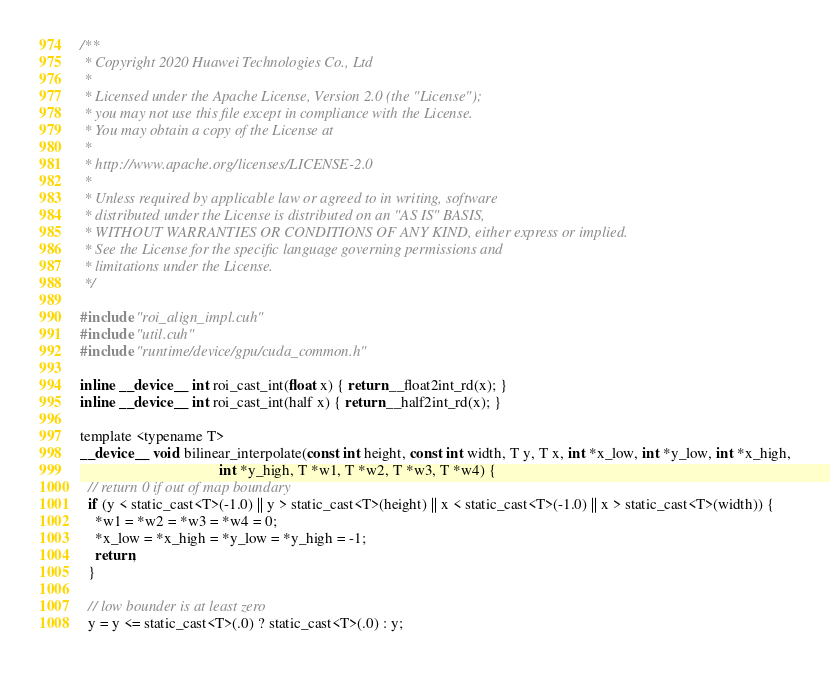<code> <loc_0><loc_0><loc_500><loc_500><_Cuda_>/**
 * Copyright 2020 Huawei Technologies Co., Ltd
 *
 * Licensed under the Apache License, Version 2.0 (the "License");
 * you may not use this file except in compliance with the License.
 * You may obtain a copy of the License at
 *
 * http://www.apache.org/licenses/LICENSE-2.0
 *
 * Unless required by applicable law or agreed to in writing, software
 * distributed under the License is distributed on an "AS IS" BASIS,
 * WITHOUT WARRANTIES OR CONDITIONS OF ANY KIND, either express or implied.
 * See the License for the specific language governing permissions and
 * limitations under the License.
 */

#include "roi_align_impl.cuh"
#include "util.cuh"
#include "runtime/device/gpu/cuda_common.h"

inline __device__ int roi_cast_int(float x) { return __float2int_rd(x); }
inline __device__ int roi_cast_int(half x) { return __half2int_rd(x); }

template <typename T>
__device__ void bilinear_interpolate(const int height, const int width, T y, T x, int *x_low, int *y_low, int *x_high,
                                     int *y_high, T *w1, T *w2, T *w3, T *w4) {
  // return 0 if out of map boundary
  if (y < static_cast<T>(-1.0) || y > static_cast<T>(height) || x < static_cast<T>(-1.0) || x > static_cast<T>(width)) {
    *w1 = *w2 = *w3 = *w4 = 0;
    *x_low = *x_high = *y_low = *y_high = -1;
    return;
  }

  // low bounder is at least zero
  y = y <= static_cast<T>(.0) ? static_cast<T>(.0) : y;</code> 